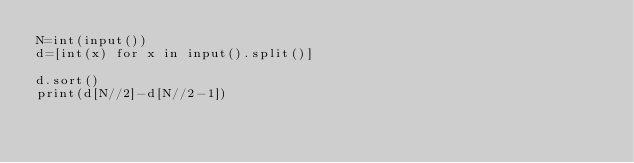<code> <loc_0><loc_0><loc_500><loc_500><_Python_>N=int(input())
d=[int(x) for x in input().split()]

d.sort()
print(d[N//2]-d[N//2-1])</code> 